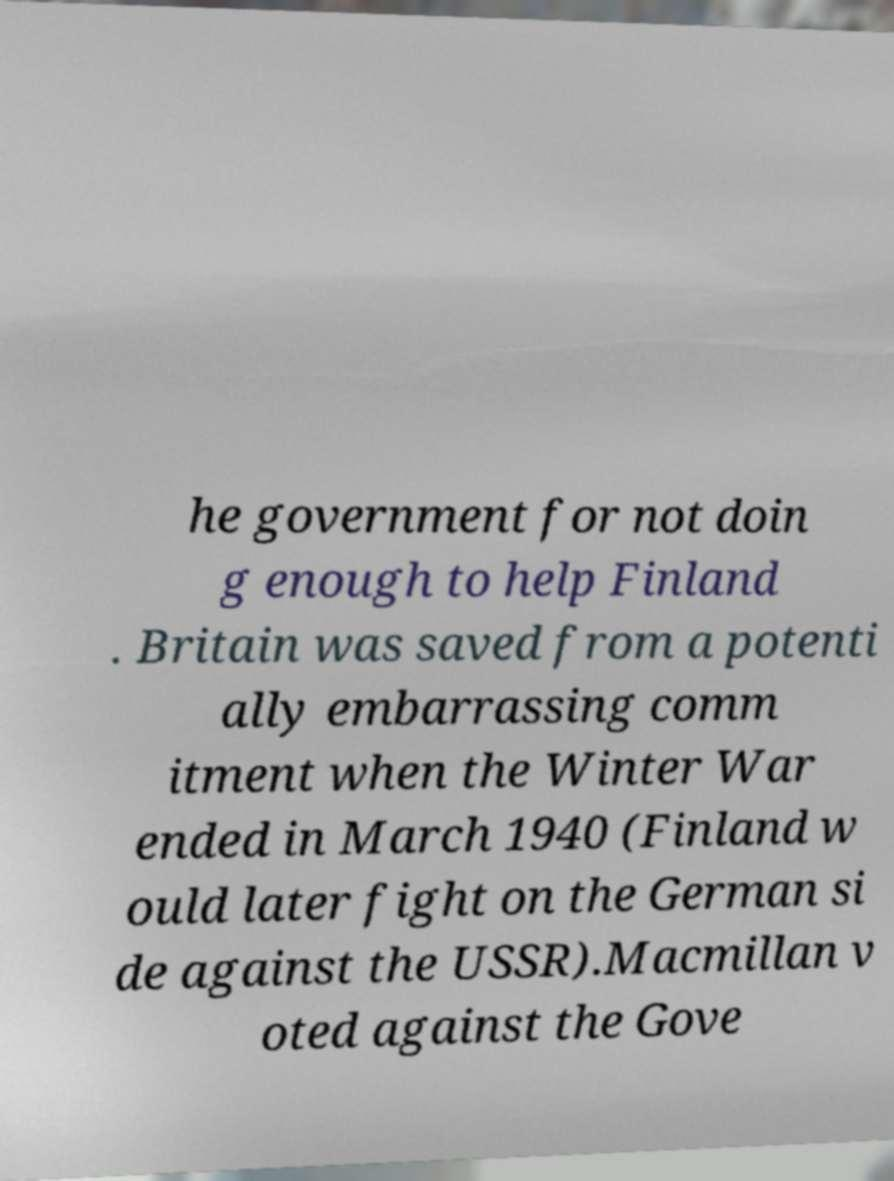Please read and relay the text visible in this image. What does it say? he government for not doin g enough to help Finland . Britain was saved from a potenti ally embarrassing comm itment when the Winter War ended in March 1940 (Finland w ould later fight on the German si de against the USSR).Macmillan v oted against the Gove 